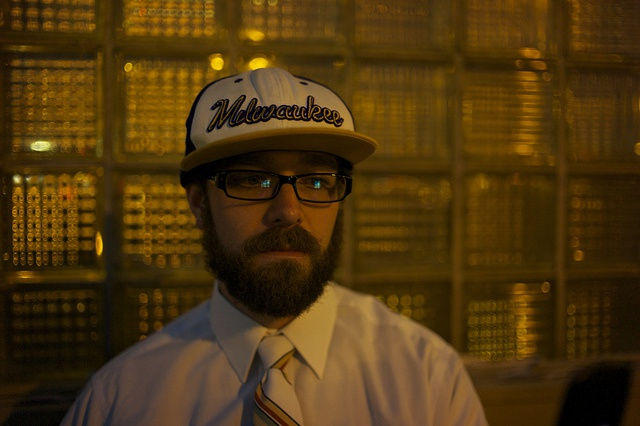Describe the objects in this image and their specific colors. I can see book in black, maroon, and olive tones, people in black, maroon, and olive tones, tie in black, olive, and maroon tones, book in black, maroon, and olive tones, and book in black, olive, and maroon tones in this image. 